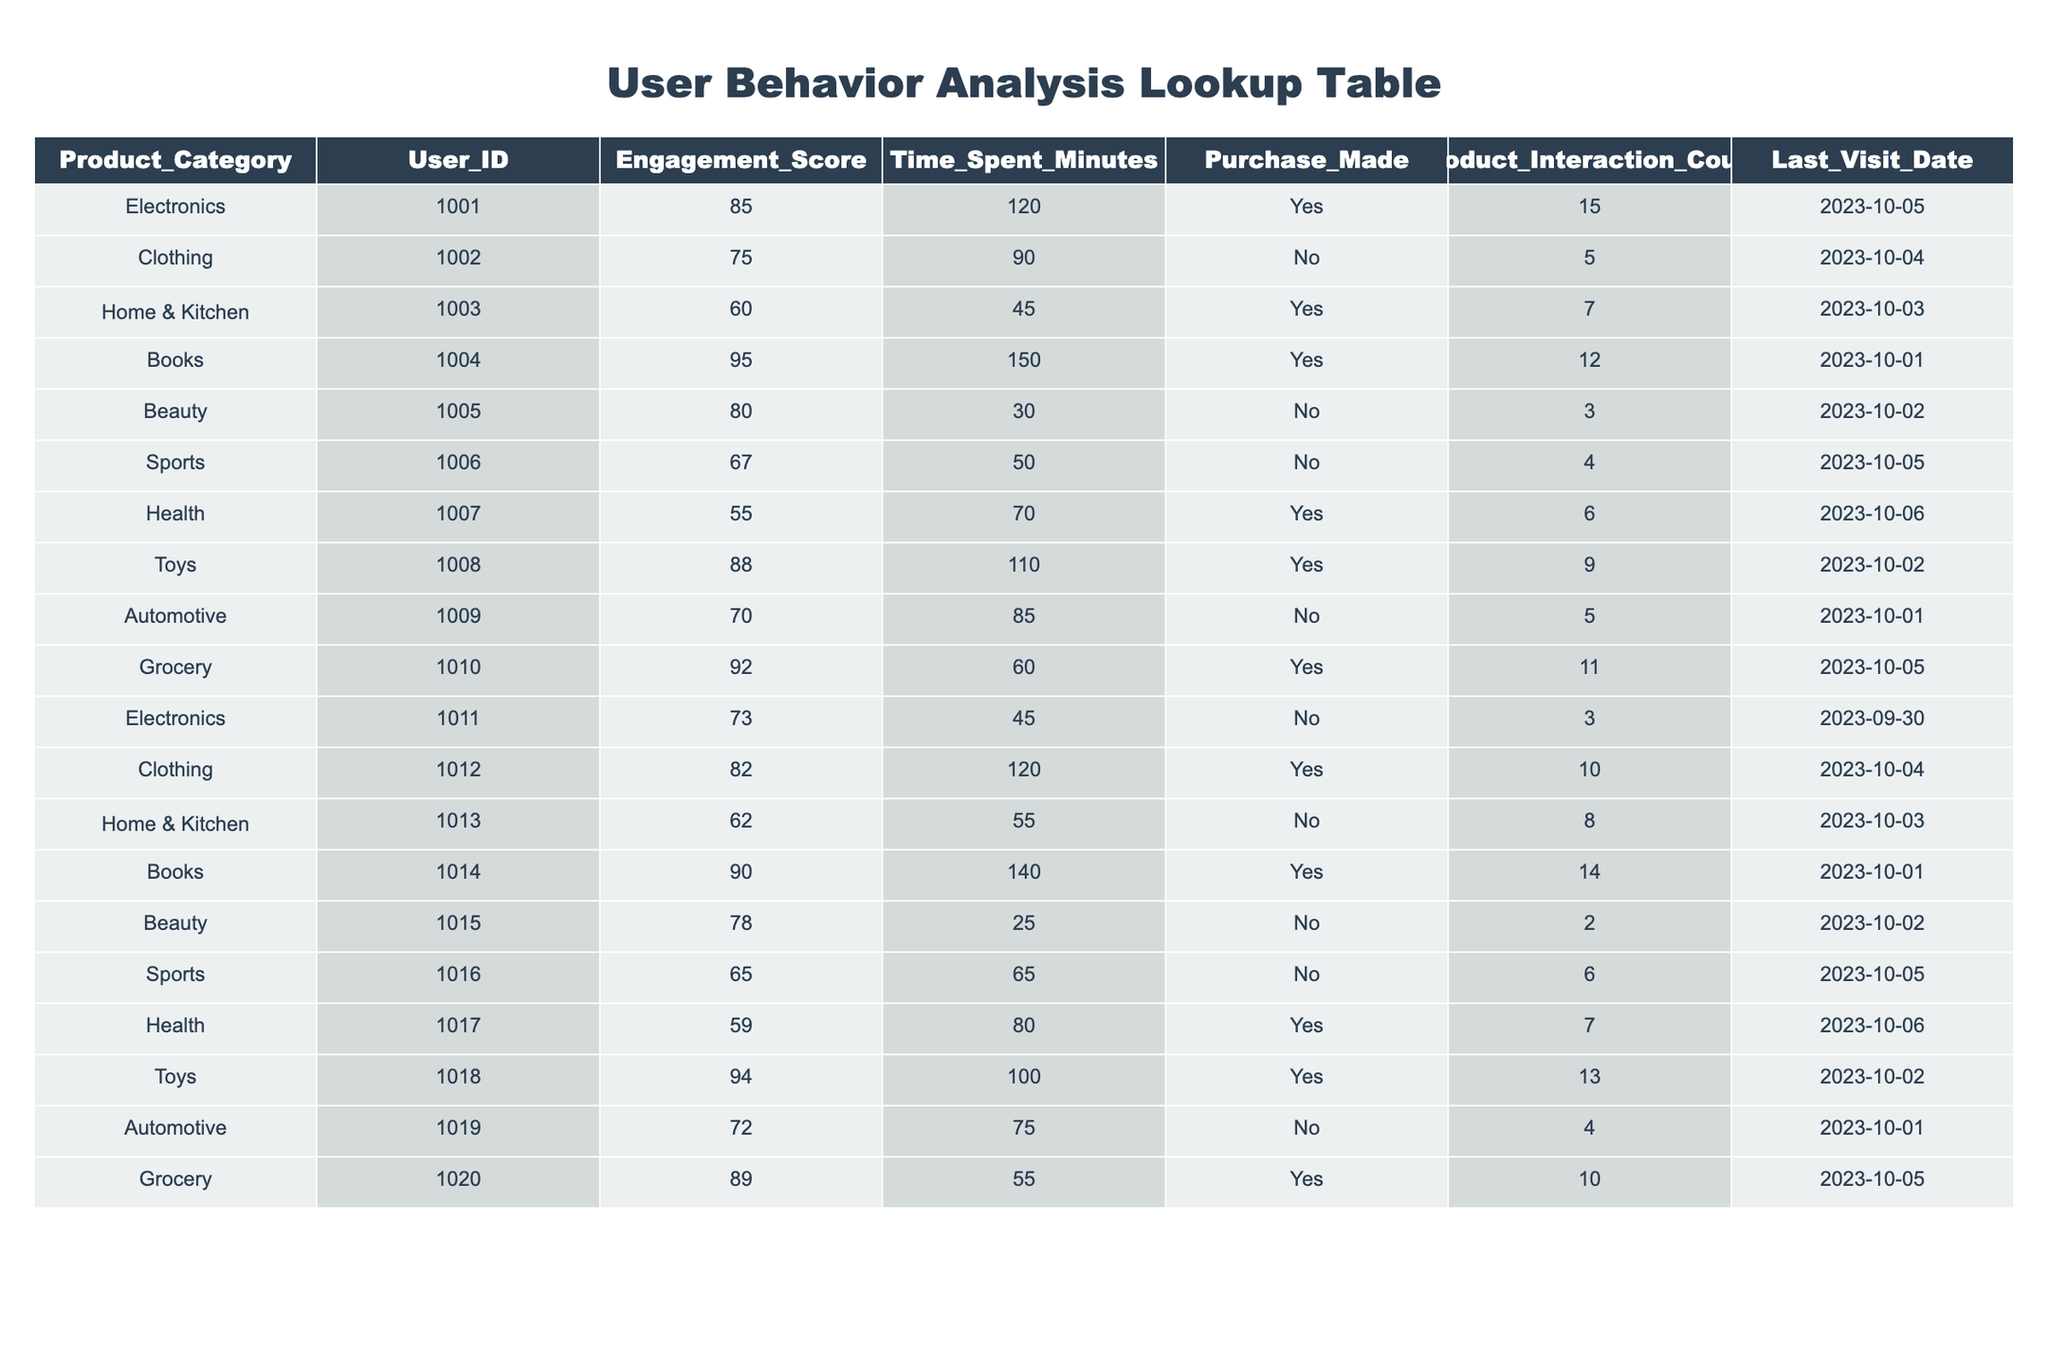What is the Engagement Score for Electronics? The table shows that the Engagement Score for the Electronics category is listed under Product_Category "Electronics" which corresponds to User_ID 1001, indicating a score of 85.
Answer: 85 How many minutes did User ID 1004 spend on Books? By looking at the row corresponding to User_ID 1004, which indicates the category as Books, we can see that the Time Spent in Minutes is 150.
Answer: 150 Is a purchase made by User ID 1016? The table indicates under Purchase_Made for User_ID 1016 that it is marked as "No," meaning that no purchase was made by this user.
Answer: No What is the average Time Spent in Minutes for users who made a purchase? We look specifically for rows where Purchase_Made is "Yes." The users who made purchases are User_IDs 1001, 1003, 1004, 1009, 1012, 1014, 1017, 1018, and 1020, yielding times of 120, 45, 150, 60, 120, 140, 80, 100, and 55 minutes respectively. The sum is 120 + 45 + 150 + 60 + 120 + 140 + 80 + 100 + 55 = 970. There are 9 entries, so the average is 970 / 9 = 107.78, rounded down to 107.
Answer: 107.78 Which product category has the highest average Engagement Score? To find this, we need to compute the average Engagement Scores for each category. The scores for each category rounded up are: Electronics (79), Clothing (78.5), Home & Kitchen (61), Books (92.5), Beauty (79), Sports (66), Health (57), Toys (91), Automotive (71), and Grocery (90.5). The highest average score was seen in the Books category with an average of 92.5.
Answer: Books Which Product Category had the highest number of Product Interactions? Looking at the Product_Interaction_Counts in the table, the maximum value is 15 for User_ID 1001 under Electronics. Therefore, Electronics had the highest number of product interactions.
Answer: Electronics How many users did not make any purchases? By filtering the Purchase_Made column for "No," we find that User_IDs 1002, 1005, 1006, 1011, 1013, 1015, and 1019 fall into this category. Counting, there are 7 users who did not make any purchases.
Answer: 7 What is the total Engagement Score for all users in the Health category? Searching in the table, we find Health has entries for User_IDs 1007 and 1017 with Engagement Scores of 55 and 59 respectively. The total Engagement Score therefore is 55 + 59 = 114.
Answer: 114 